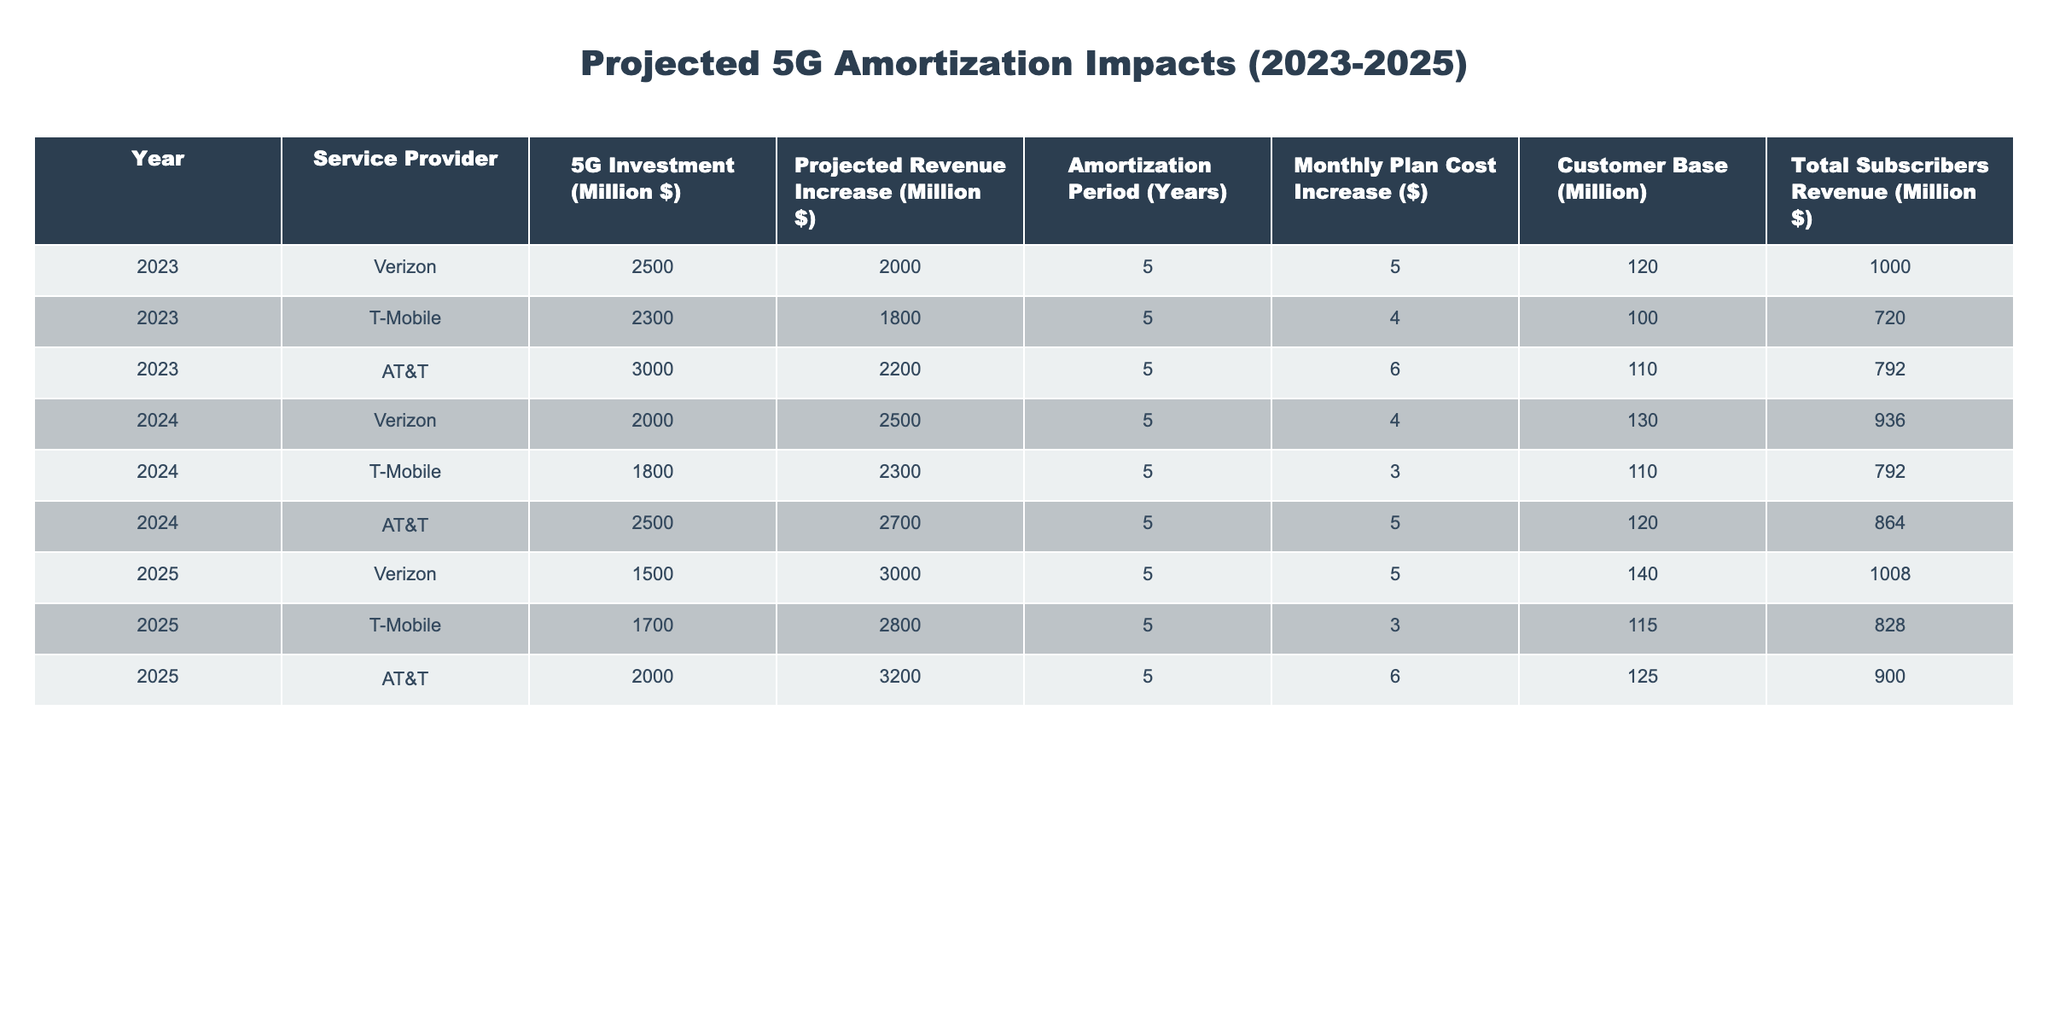What is the total projected revenue increase for AT&T in 2025? The projected revenue increase for AT&T in 2025 is stated directly in the table as 3200 million dollars.
Answer: 3200 million dollars What was the monthly plan cost increase for T-Mobile in 2024? The monthly plan cost increase for T-Mobile in 2024 is listed directly in the table as 3 dollars.
Answer: 3 dollars Which service provider had the highest 5G investment in 2023? The table shows Verizon with a 5G investment of 2500 million dollars, which is higher than both T-Mobile's 2300 million dollars and AT&T's 3000 million dollars.
Answer: AT&T What is the average monthly plan cost increase for all service providers in 2023? The monthly plan cost increases for 2023 are 5, 4, and 6 dollars. The sum is 5 + 4 + 6 = 15 dollars. There are three service providers, so the average is 15 / 3 = 5 dollars.
Answer: 5 dollars Is the total subscribers revenue for Verizon increasing from 2023 to 2025? In 2023, Verizon's total subscribers revenue is 1000 million dollars, and in 2025 it is 1008 million dollars. Since 1008 is greater than 1000, the revenue is indeed increasing.
Answer: Yes What is the difference in projected revenue increase between T-Mobile in 2023 and 2024? T-Mobile's projected revenue increase is 1800 million dollars in 2023 and 2300 million dollars in 2024. The difference is 2300 - 1800 = 500 million dollars.
Answer: 500 million dollars What percentage of the total subscribers revenue does AT&T generate in 2023? AT&T generated 792 million dollars in total subscribers revenue in 2023. The total subscribers revenue across all providers in 2023 is 1000 + 720 + 792 = 2512 million dollars. The percentage is (792 / 2512) * 100 = 31.5%.
Answer: 31.5% Which provider had the lowest total subscribers revenue in 2024? The total subscribers revenue for AT&T in 2024 is 864 million dollars, while Verizon's revenue is 936 million dollars and T-Mobile's is 792 million dollars. Thus, T-Mobile has the lowest.
Answer: T-Mobile What is the total 5G investment for all service providers in 2023? The 5G investments for 2023 are 2500 million dollars (Verizon), 2300 million dollars (T-Mobile), and 3000 million dollars (AT&T). The total is 2500 + 2300 + 3000 = 7800 million dollars.
Answer: 7800 million dollars 